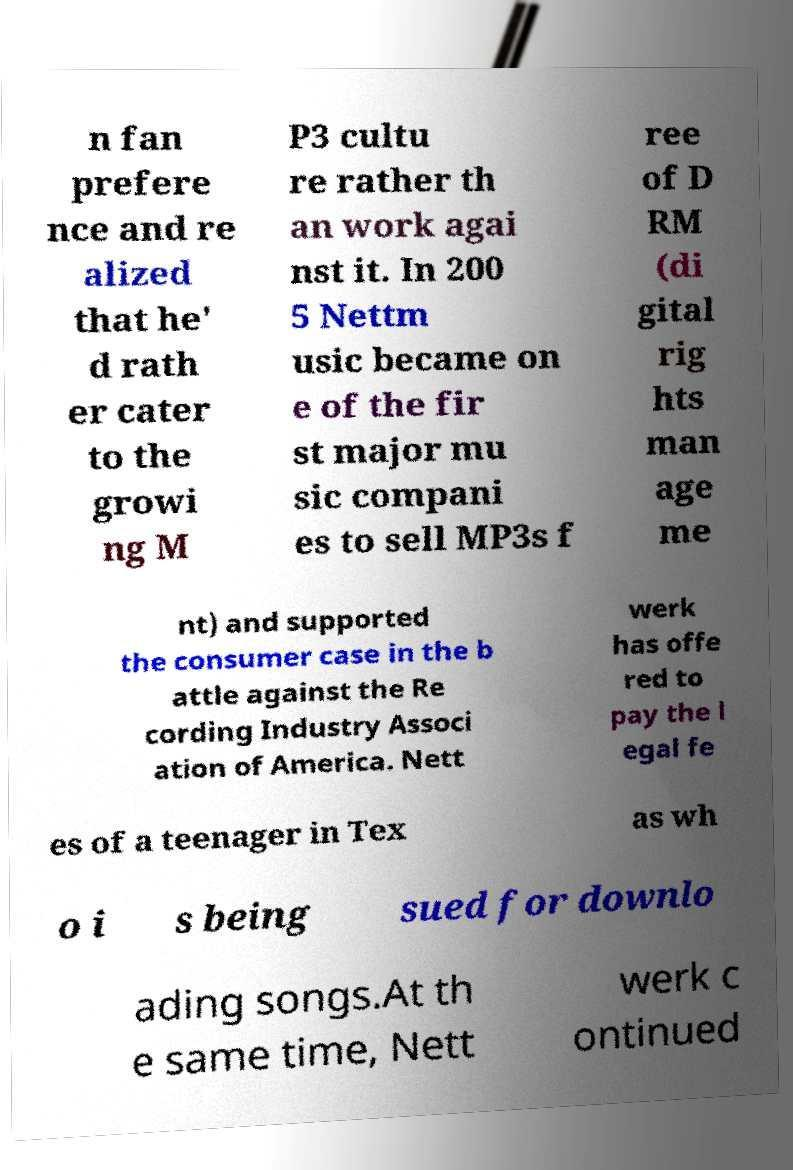Please read and relay the text visible in this image. What does it say? n fan prefere nce and re alized that he' d rath er cater to the growi ng M P3 cultu re rather th an work agai nst it. In 200 5 Nettm usic became on e of the fir st major mu sic compani es to sell MP3s f ree of D RM (di gital rig hts man age me nt) and supported the consumer case in the b attle against the Re cording Industry Associ ation of America. Nett werk has offe red to pay the l egal fe es of a teenager in Tex as wh o i s being sued for downlo ading songs.At th e same time, Nett werk c ontinued 